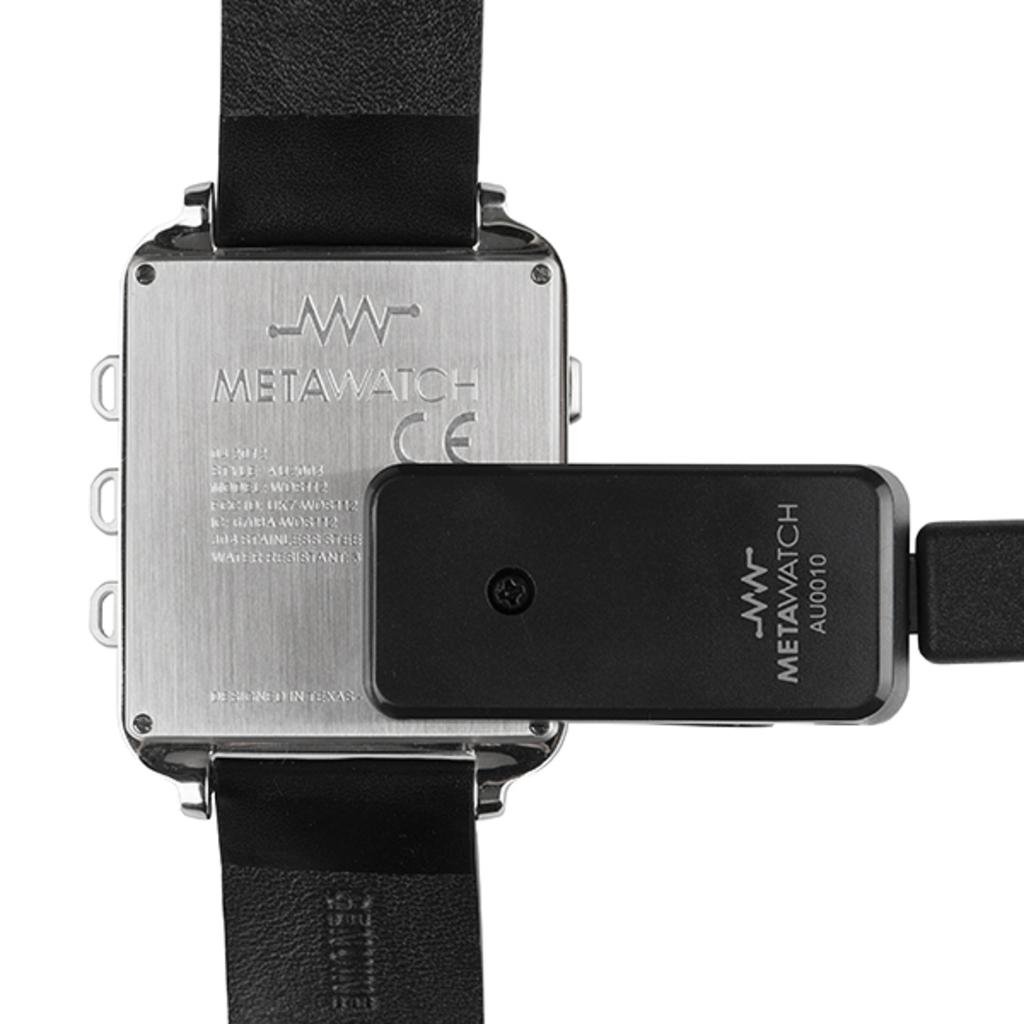<image>
Give a short and clear explanation of the subsequent image. The back of a a Metawatch wrist watch attached with black straps. 